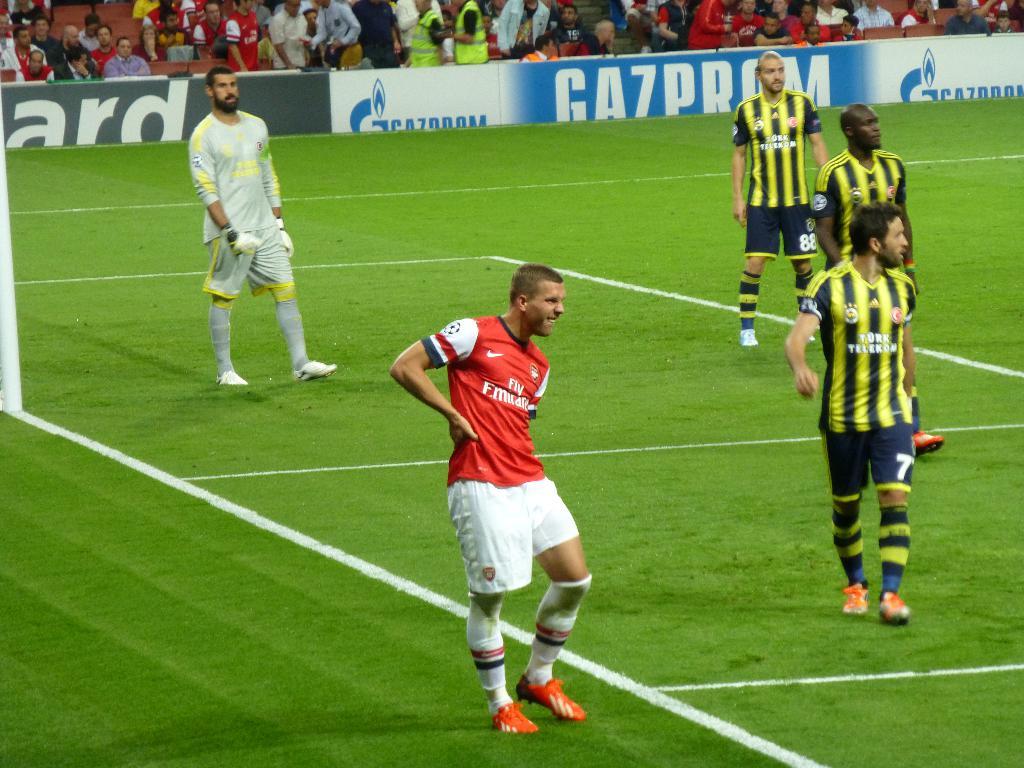Is gazprom an advertiser here?
Provide a short and direct response. Yes. What is the game name?
Make the answer very short. Answering does not require reading text in the image. 